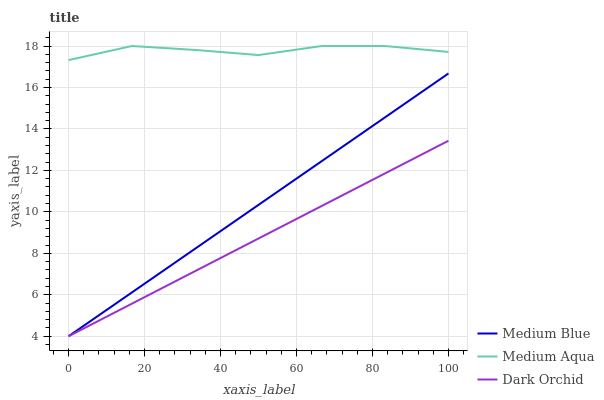Does Dark Orchid have the minimum area under the curve?
Answer yes or no. Yes. Does Medium Aqua have the maximum area under the curve?
Answer yes or no. Yes. Does Medium Blue have the minimum area under the curve?
Answer yes or no. No. Does Medium Blue have the maximum area under the curve?
Answer yes or no. No. Is Medium Blue the smoothest?
Answer yes or no. Yes. Is Medium Aqua the roughest?
Answer yes or no. Yes. Is Dark Orchid the smoothest?
Answer yes or no. No. Is Dark Orchid the roughest?
Answer yes or no. No. Does Medium Aqua have the highest value?
Answer yes or no. Yes. Does Medium Blue have the highest value?
Answer yes or no. No. Is Medium Blue less than Medium Aqua?
Answer yes or no. Yes. Is Medium Aqua greater than Medium Blue?
Answer yes or no. Yes. Does Medium Blue intersect Dark Orchid?
Answer yes or no. Yes. Is Medium Blue less than Dark Orchid?
Answer yes or no. No. Is Medium Blue greater than Dark Orchid?
Answer yes or no. No. Does Medium Blue intersect Medium Aqua?
Answer yes or no. No. 